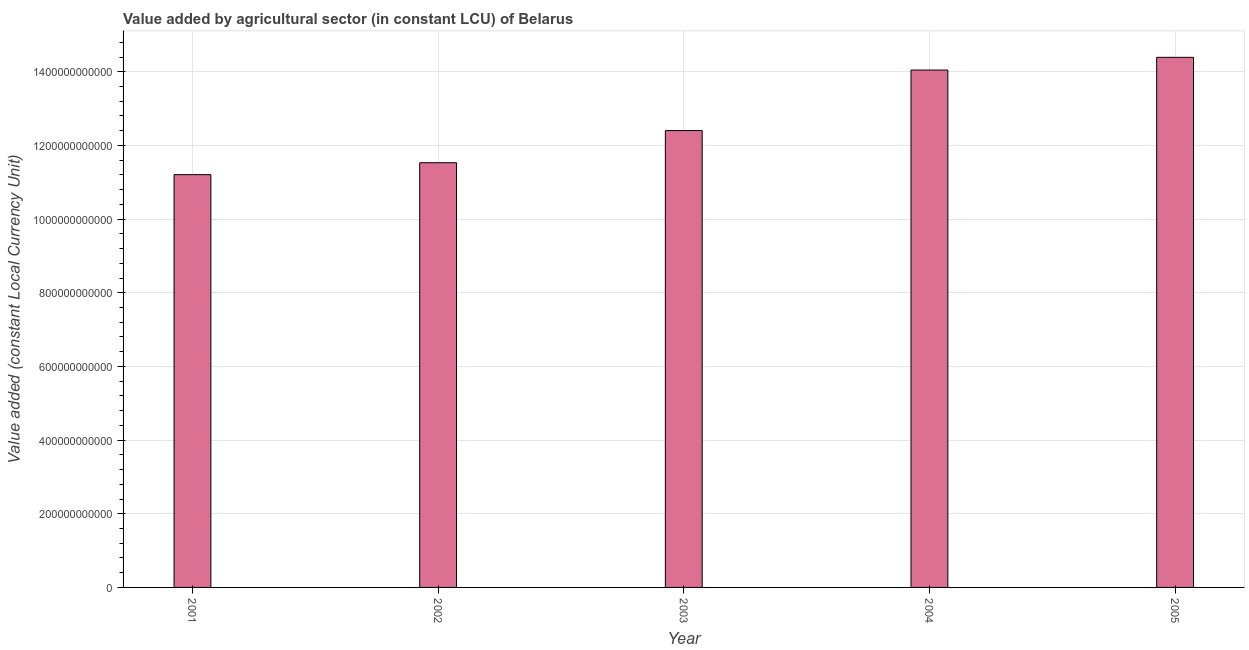What is the title of the graph?
Your answer should be compact. Value added by agricultural sector (in constant LCU) of Belarus. What is the label or title of the Y-axis?
Ensure brevity in your answer.  Value added (constant Local Currency Unit). What is the value added by agriculture sector in 2004?
Keep it short and to the point. 1.40e+12. Across all years, what is the maximum value added by agriculture sector?
Provide a succinct answer. 1.44e+12. Across all years, what is the minimum value added by agriculture sector?
Your response must be concise. 1.12e+12. What is the sum of the value added by agriculture sector?
Ensure brevity in your answer.  6.36e+12. What is the difference between the value added by agriculture sector in 2002 and 2003?
Provide a succinct answer. -8.73e+1. What is the average value added by agriculture sector per year?
Your answer should be very brief. 1.27e+12. What is the median value added by agriculture sector?
Your response must be concise. 1.24e+12. Do a majority of the years between 2002 and 2001 (inclusive) have value added by agriculture sector greater than 880000000000 LCU?
Provide a short and direct response. No. What is the ratio of the value added by agriculture sector in 2003 to that in 2005?
Offer a terse response. 0.86. Is the value added by agriculture sector in 2003 less than that in 2004?
Keep it short and to the point. Yes. What is the difference between the highest and the second highest value added by agriculture sector?
Provide a short and direct response. 3.45e+1. Is the sum of the value added by agriculture sector in 2003 and 2004 greater than the maximum value added by agriculture sector across all years?
Ensure brevity in your answer.  Yes. What is the difference between the highest and the lowest value added by agriculture sector?
Your answer should be very brief. 3.19e+11. In how many years, is the value added by agriculture sector greater than the average value added by agriculture sector taken over all years?
Your response must be concise. 2. How many bars are there?
Offer a very short reply. 5. Are all the bars in the graph horizontal?
Ensure brevity in your answer.  No. What is the difference between two consecutive major ticks on the Y-axis?
Offer a terse response. 2.00e+11. Are the values on the major ticks of Y-axis written in scientific E-notation?
Give a very brief answer. No. What is the Value added (constant Local Currency Unit) of 2001?
Provide a succinct answer. 1.12e+12. What is the Value added (constant Local Currency Unit) of 2002?
Keep it short and to the point. 1.15e+12. What is the Value added (constant Local Currency Unit) of 2003?
Provide a succinct answer. 1.24e+12. What is the Value added (constant Local Currency Unit) of 2004?
Keep it short and to the point. 1.40e+12. What is the Value added (constant Local Currency Unit) of 2005?
Offer a very short reply. 1.44e+12. What is the difference between the Value added (constant Local Currency Unit) in 2001 and 2002?
Make the answer very short. -3.24e+1. What is the difference between the Value added (constant Local Currency Unit) in 2001 and 2003?
Keep it short and to the point. -1.20e+11. What is the difference between the Value added (constant Local Currency Unit) in 2001 and 2004?
Your answer should be compact. -2.84e+11. What is the difference between the Value added (constant Local Currency Unit) in 2001 and 2005?
Your response must be concise. -3.19e+11. What is the difference between the Value added (constant Local Currency Unit) in 2002 and 2003?
Keep it short and to the point. -8.73e+1. What is the difference between the Value added (constant Local Currency Unit) in 2002 and 2004?
Offer a terse response. -2.52e+11. What is the difference between the Value added (constant Local Currency Unit) in 2002 and 2005?
Give a very brief answer. -2.86e+11. What is the difference between the Value added (constant Local Currency Unit) in 2003 and 2004?
Provide a short and direct response. -1.64e+11. What is the difference between the Value added (constant Local Currency Unit) in 2003 and 2005?
Provide a succinct answer. -1.99e+11. What is the difference between the Value added (constant Local Currency Unit) in 2004 and 2005?
Keep it short and to the point. -3.45e+1. What is the ratio of the Value added (constant Local Currency Unit) in 2001 to that in 2002?
Offer a very short reply. 0.97. What is the ratio of the Value added (constant Local Currency Unit) in 2001 to that in 2003?
Offer a terse response. 0.9. What is the ratio of the Value added (constant Local Currency Unit) in 2001 to that in 2004?
Offer a terse response. 0.8. What is the ratio of the Value added (constant Local Currency Unit) in 2001 to that in 2005?
Give a very brief answer. 0.78. What is the ratio of the Value added (constant Local Currency Unit) in 2002 to that in 2003?
Make the answer very short. 0.93. What is the ratio of the Value added (constant Local Currency Unit) in 2002 to that in 2004?
Provide a succinct answer. 0.82. What is the ratio of the Value added (constant Local Currency Unit) in 2002 to that in 2005?
Make the answer very short. 0.8. What is the ratio of the Value added (constant Local Currency Unit) in 2003 to that in 2004?
Make the answer very short. 0.88. What is the ratio of the Value added (constant Local Currency Unit) in 2003 to that in 2005?
Your response must be concise. 0.86. 